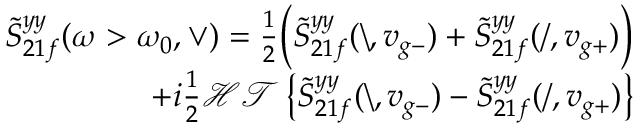Convert formula to latex. <formula><loc_0><loc_0><loc_500><loc_500>\begin{array} { r } { \tilde { S } _ { 2 1 f } ^ { y y } ( \omega > \omega _ { 0 } , \vee ) = \frac { 1 } { 2 } \left ( \tilde { S } _ { 2 1 f } ^ { y y } ( \ , v _ { g - } ) + \tilde { S } _ { 2 1 f } ^ { y y } ( / , v _ { g + } ) \right ) } \\ { + i \frac { 1 } { 2 } \mathcal { H T } \left \{ \tilde { S } _ { 2 1 f } ^ { y y } ( \ , v _ { g - } ) - \tilde { S } _ { 2 1 f } ^ { y y } ( / , v _ { g + } ) \right \} } \end{array}</formula> 